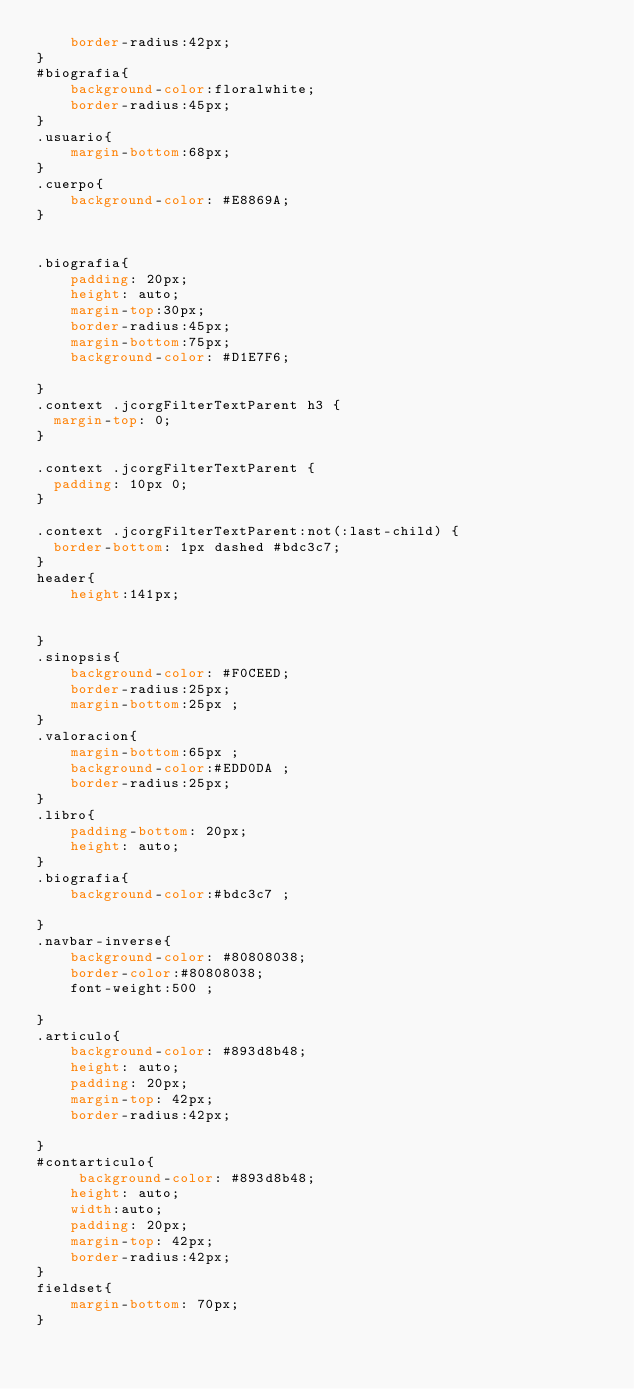Convert code to text. <code><loc_0><loc_0><loc_500><loc_500><_CSS_>    border-radius:42px;
}
#biografia{
    background-color:floralwhite;
    border-radius:45px;
}
.usuario{
	margin-bottom:68px;
}
.cuerpo{
    background-color: #E8869A;
}


.biografia{
    padding: 20px;
    height: auto;
    margin-top:30px;
    border-radius:45px;
    margin-bottom:75px;
    background-color: #D1E7F6;
    
}
.context .jcorgFilterTextParent h3 {
  margin-top: 0;
}

.context .jcorgFilterTextParent {
  padding: 10px 0;
}

.context .jcorgFilterTextParent:not(:last-child) {
  border-bottom: 1px dashed #bdc3c7;
}
header{
	height:141px;
	
	
}
.sinopsis{
	background-color: #F0CEED;
	border-radius:25px;
	margin-bottom:25px ;
}
.valoracion{
	margin-bottom:65px ;
	background-color:#EDD0DA ;
	border-radius:25px;
}
.libro{
	padding-bottom: 20px;
	height: auto;
}
.biografia{
	background-color:#bdc3c7 ;
	
}
.navbar-inverse{
	background-color: #80808038;
	border-color:#80808038;
	font-weight:500 ;
	
}
.articulo{
	background-color: #893d8b48;
    height: auto;
    padding: 20px;
    margin-top: 42px;
    border-radius:42px;
   
}
#contarticulo{
	 background-color: #893d8b48;
    height: auto;
    width:auto;
    padding: 20px;
    margin-top: 42px;
    border-radius:42px;
}
fieldset{
	margin-bottom: 70px;
}
</code> 